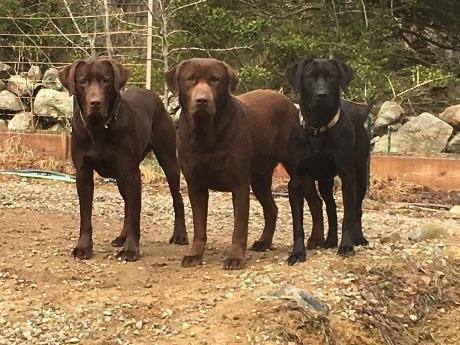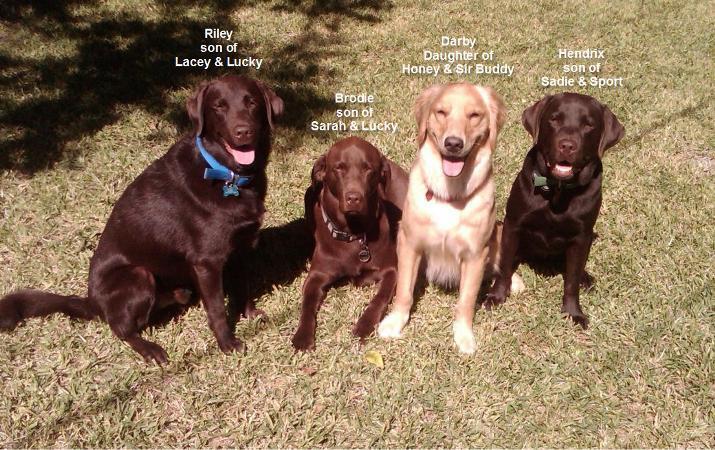The first image is the image on the left, the second image is the image on the right. Considering the images on both sides, is "The image on the right shows a group of dogs that are all sitting or lying down, and all but one of the dogs are showing their tongues." valid? Answer yes or no. Yes. 